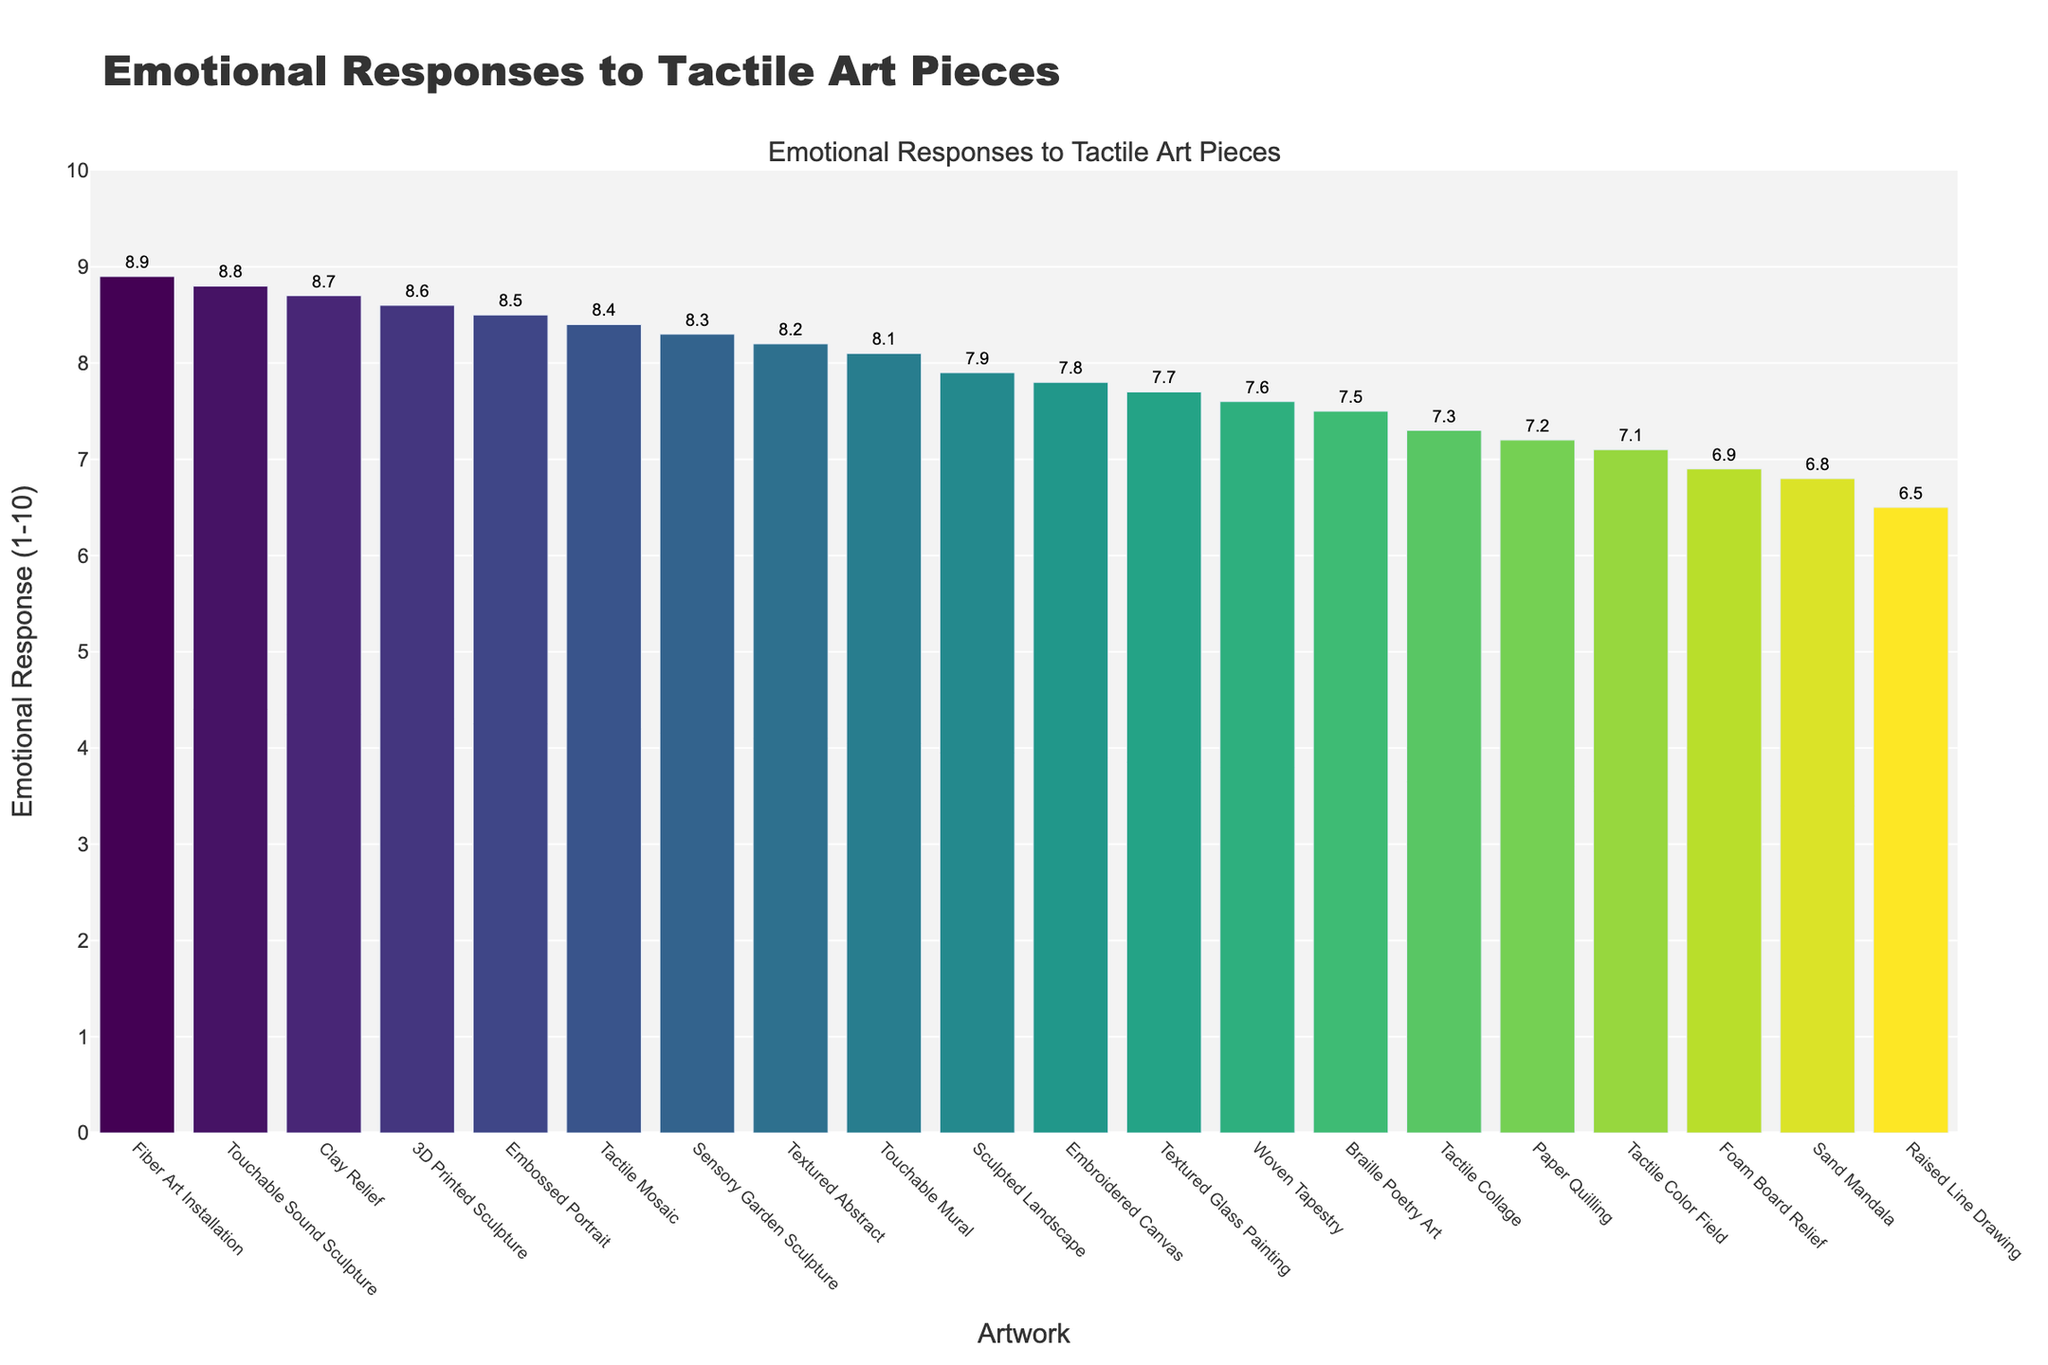What tactile art piece received the highest emotional response? The bar representing the "Fiber Art Installation" has the highest length, indicating it received the highest emotional response.
Answer: Fiber Art Installation Which artwork has a higher emotional response, "Embossed Portrait" or "Touchable Mural"? By comparing the heights of the bars, "Embossed Portrait" has a higher bar than "Touchable Mural", indicating a higher emotional response.
Answer: Embossed Portrait What is the average emotional response of all the tactile art pieces? Sum the emotional responses of all the artwork (8.2 + 7.9 + 8.5 + 7.6 + 6.8 + 8.7 + 7.3 + 6.5 + 8.9 + 8.1 + 7.2 + 8.4 + 7.8 + 8.6 + 7.5 + 8.3 + 7.7 + 6.9 + 8.8 + 7.1) which equals 155.8, then divide by the number of artworks which is 20. 155.8 / 20 = 7.79
Answer: 7.79 Which tactile art piece has an emotional response closest to the median? To find the median, sort the emotional responses and find the middle number. Sorting: 6.5, 6.8, 6.9, 7.1, 7.2, 7.3, 7.5, 7.6, 7.7, 7.8, 7.9, 8.1, 8.2, 8.3, 8.4, 8.5, 8.6, 8.7, 8.8, 8.9. The median is the average of the 10th and 11th values (7.8 and 7.9): (7.8+7.9)/2 = 7.85. The closest emotional response to 7.85 is "Embossed Portrait" (8.5).
Answer: Embossed Portrait How much higher is the response to "Touchable Sound Sculpture" compared to "Raised Line Drawing"? Subtract the emotional response of "Raised Line Drawing" (6.5) from "Touchable Sound Sculpture" (8.8): 8.8 - 6.5 = 2.3
Answer: 2.3 What is the combined emotional response of "Textured Abstract" and "Clay Relief"? Add the emotional responses of "Textured Abstract" (8.2) and "Clay Relief" (8.7): 8.2 + 8.7 = 16.9
Answer: 16.9 Which artwork received a lower emotional response, "Embroidered Canvas" or "Tactile Mosaic"? By comparing the lengths of the bars, "Embroidered Canvas" has a lower bar than "Tactile Mosaic", indicating a lower emotional response.
Answer: Embroidered Canvas Identify the artwork with an emotional response of 7.6. Locate the bar that corresponds to 7.6 on the y-axis, which is labeled as "Woven Tapestry".
Answer: Woven Tapestry What is the range of the emotional responses shown in the chart? The range is calculated as the difference between the highest emotional response (8.9 from "Fiber Art Installation") and the lowest emotional response (6.5 from "Raised Line Drawing"): 8.9 - 6.5 = 2.4
Answer: 2.4 